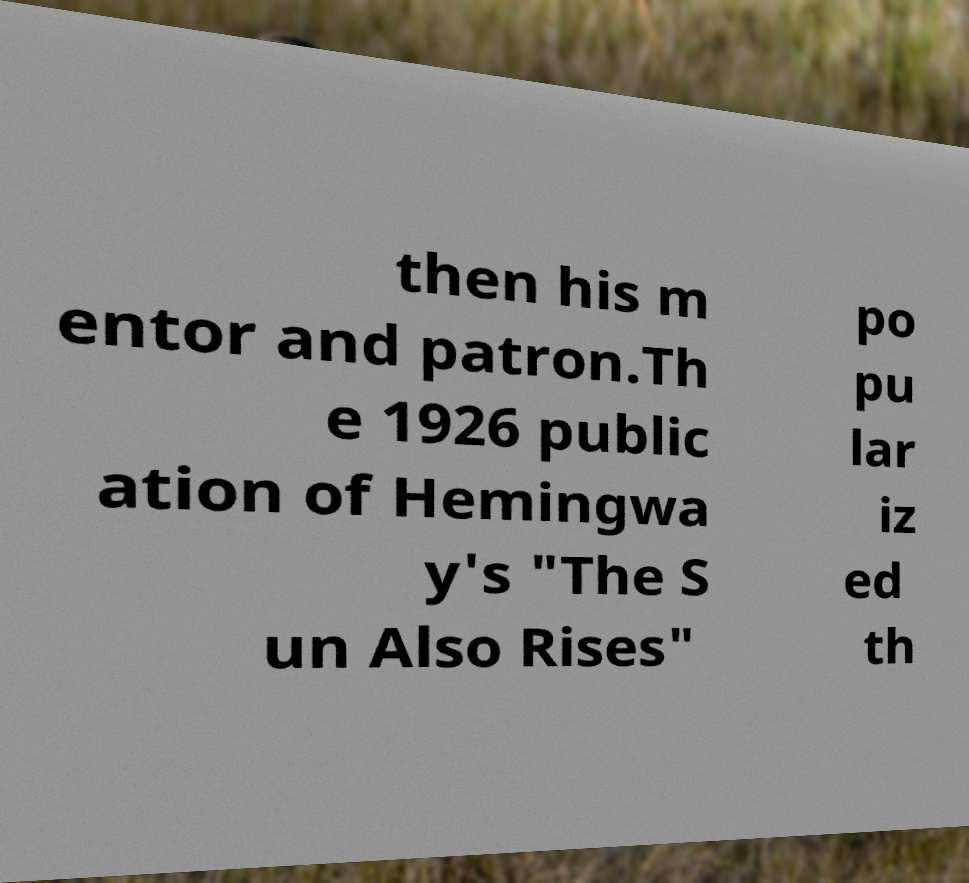Could you assist in decoding the text presented in this image and type it out clearly? then his m entor and patron.Th e 1926 public ation of Hemingwa y's "The S un Also Rises" po pu lar iz ed th 